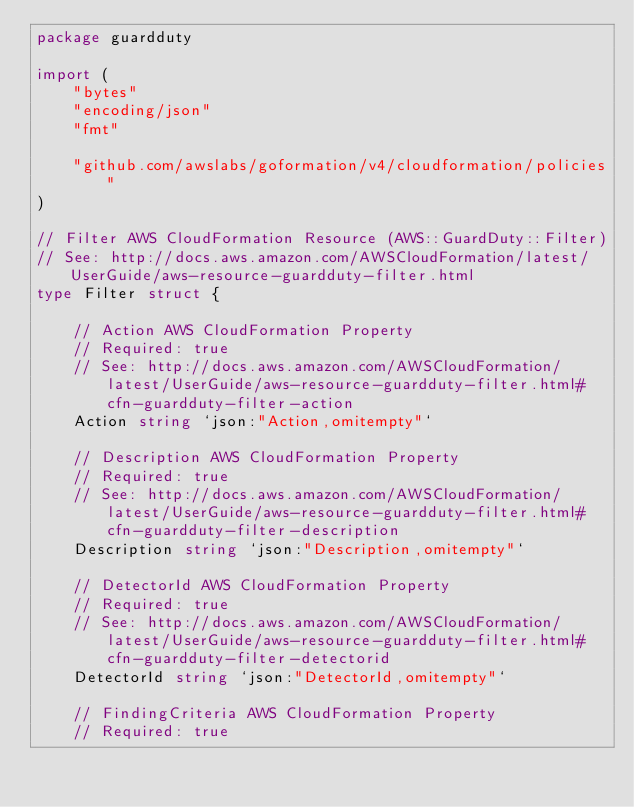Convert code to text. <code><loc_0><loc_0><loc_500><loc_500><_Go_>package guardduty

import (
	"bytes"
	"encoding/json"
	"fmt"

	"github.com/awslabs/goformation/v4/cloudformation/policies"
)

// Filter AWS CloudFormation Resource (AWS::GuardDuty::Filter)
// See: http://docs.aws.amazon.com/AWSCloudFormation/latest/UserGuide/aws-resource-guardduty-filter.html
type Filter struct {

	// Action AWS CloudFormation Property
	// Required: true
	// See: http://docs.aws.amazon.com/AWSCloudFormation/latest/UserGuide/aws-resource-guardduty-filter.html#cfn-guardduty-filter-action
	Action string `json:"Action,omitempty"`

	// Description AWS CloudFormation Property
	// Required: true
	// See: http://docs.aws.amazon.com/AWSCloudFormation/latest/UserGuide/aws-resource-guardduty-filter.html#cfn-guardduty-filter-description
	Description string `json:"Description,omitempty"`

	// DetectorId AWS CloudFormation Property
	// Required: true
	// See: http://docs.aws.amazon.com/AWSCloudFormation/latest/UserGuide/aws-resource-guardduty-filter.html#cfn-guardduty-filter-detectorid
	DetectorId string `json:"DetectorId,omitempty"`

	// FindingCriteria AWS CloudFormation Property
	// Required: true</code> 